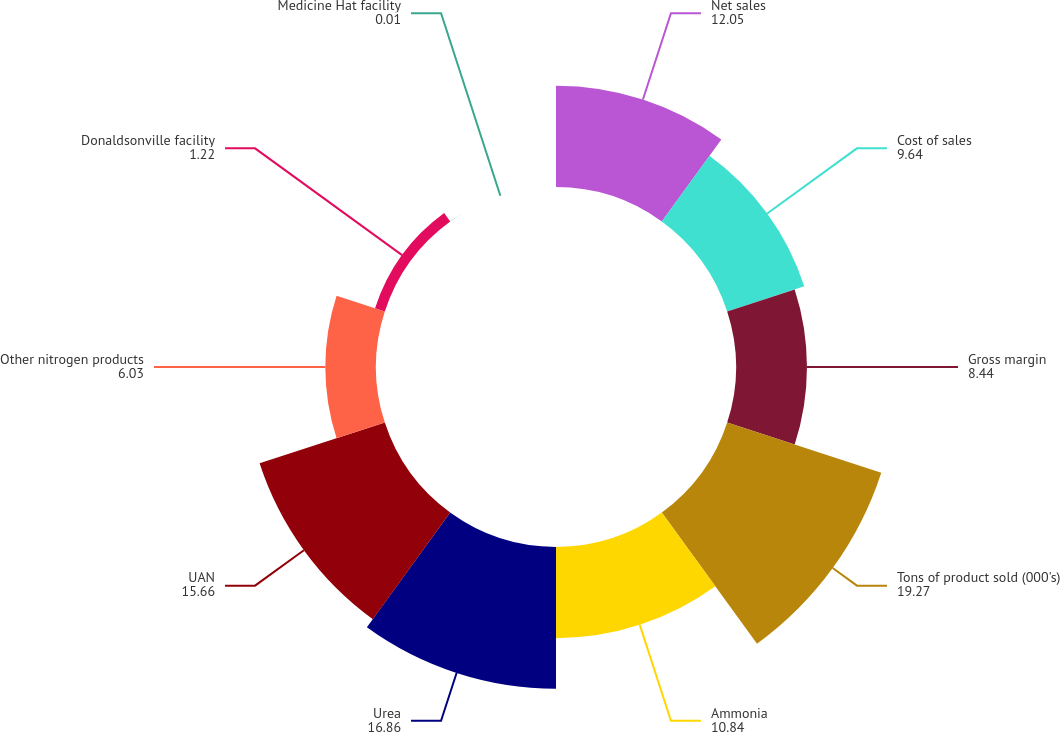<chart> <loc_0><loc_0><loc_500><loc_500><pie_chart><fcel>Net sales<fcel>Cost of sales<fcel>Gross margin<fcel>Tons of product sold (000's)<fcel>Ammonia<fcel>Urea<fcel>UAN<fcel>Other nitrogen products<fcel>Donaldsonville facility<fcel>Medicine Hat facility<nl><fcel>12.05%<fcel>9.64%<fcel>8.44%<fcel>19.27%<fcel>10.84%<fcel>16.86%<fcel>15.66%<fcel>6.03%<fcel>1.22%<fcel>0.01%<nl></chart> 